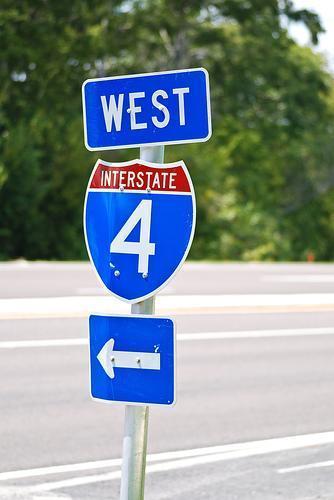How many signs are on the post?
Give a very brief answer. 3. 